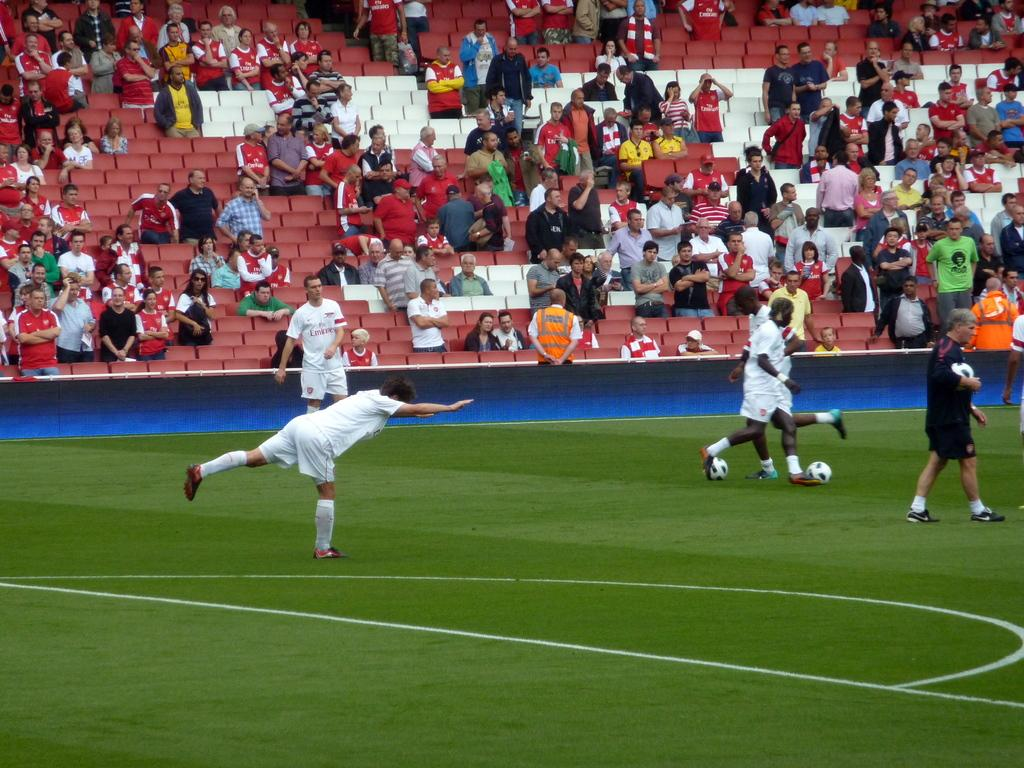Provide a one-sentence caption for the provided image. soccer players in a field wearing Emirates jerseys. 